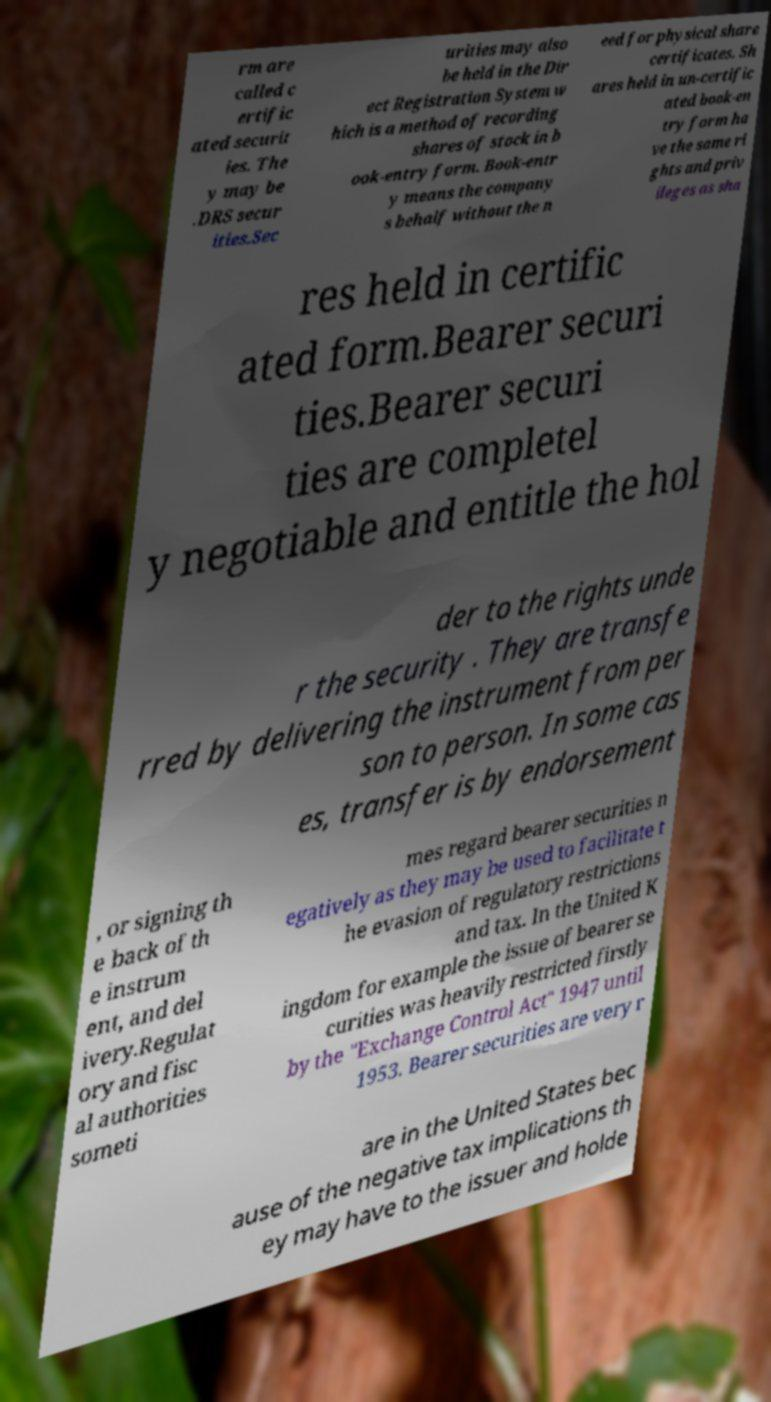Could you assist in decoding the text presented in this image and type it out clearly? rm are called c ertific ated securit ies. The y may be .DRS secur ities.Sec urities may also be held in the Dir ect Registration System w hich is a method of recording shares of stock in b ook-entry form. Book-entr y means the company s behalf without the n eed for physical share certificates. Sh ares held in un-certific ated book-en try form ha ve the same ri ghts and priv ileges as sha res held in certific ated form.Bearer securi ties.Bearer securi ties are completel y negotiable and entitle the hol der to the rights unde r the security . They are transfe rred by delivering the instrument from per son to person. In some cas es, transfer is by endorsement , or signing th e back of th e instrum ent, and del ivery.Regulat ory and fisc al authorities someti mes regard bearer securities n egatively as they may be used to facilitate t he evasion of regulatory restrictions and tax. In the United K ingdom for example the issue of bearer se curities was heavily restricted firstly by the "Exchange Control Act" 1947 until 1953. Bearer securities are very r are in the United States bec ause of the negative tax implications th ey may have to the issuer and holde 